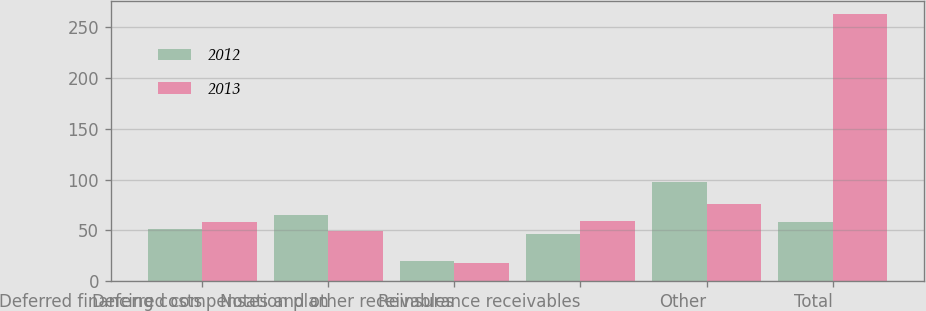<chart> <loc_0><loc_0><loc_500><loc_500><stacked_bar_chart><ecel><fcel>Deferred financing costs<fcel>Deferred compensation plan<fcel>Notes and other receivables<fcel>Reinsurance receivables<fcel>Other<fcel>Total<nl><fcel>2012<fcel>51.4<fcel>65.1<fcel>19.5<fcel>46.9<fcel>98<fcel>58.8<nl><fcel>2013<fcel>58.8<fcel>49.9<fcel>17.9<fcel>59.7<fcel>76.1<fcel>262.4<nl></chart> 